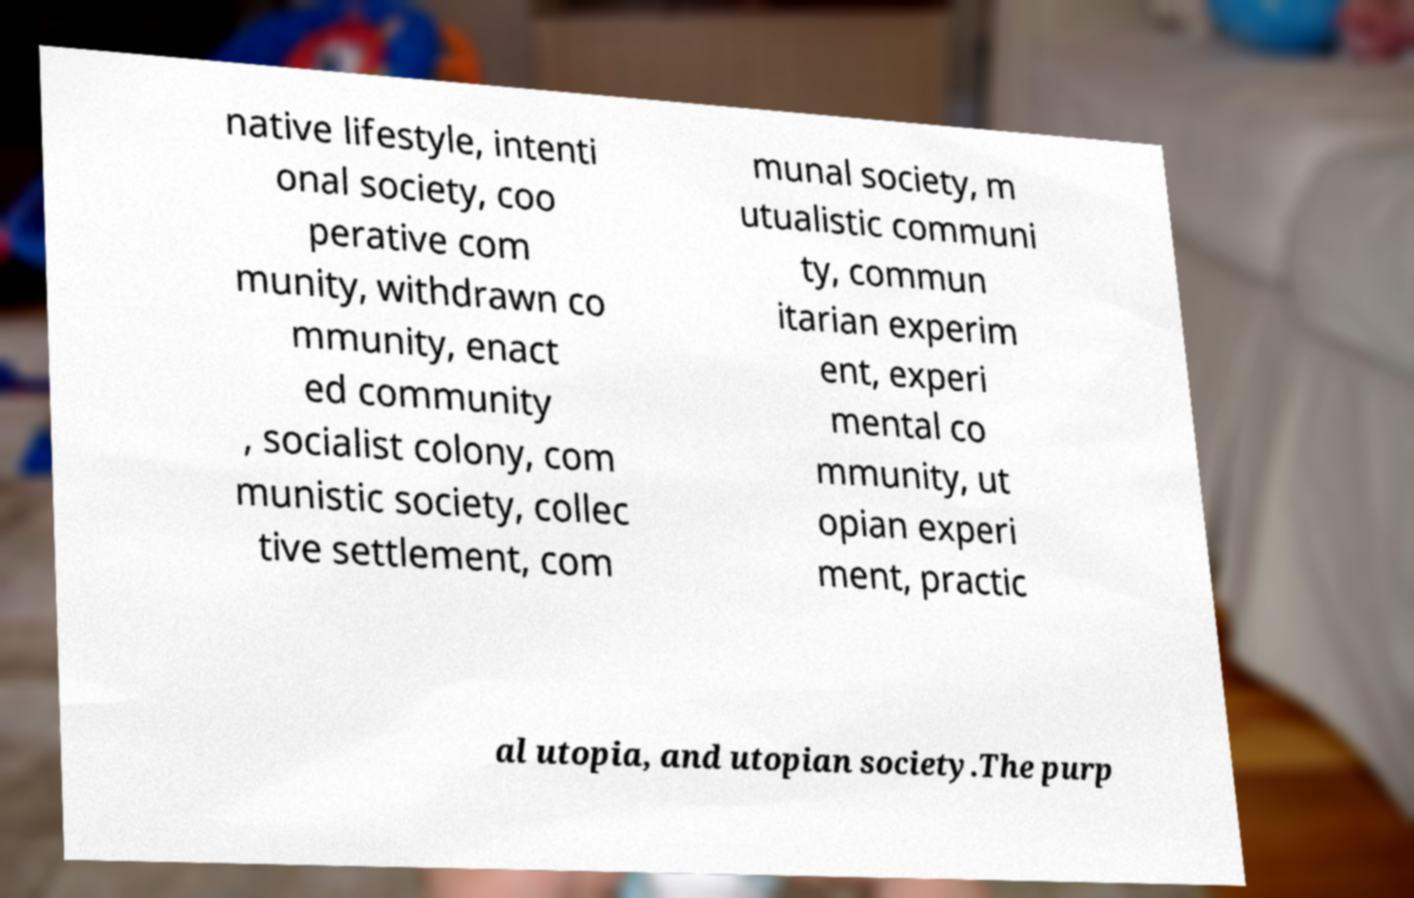I need the written content from this picture converted into text. Can you do that? native lifestyle, intenti onal society, coo perative com munity, withdrawn co mmunity, enact ed community , socialist colony, com munistic society, collec tive settlement, com munal society, m utualistic communi ty, commun itarian experim ent, experi mental co mmunity, ut opian experi ment, practic al utopia, and utopian society.The purp 